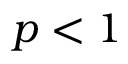<formula> <loc_0><loc_0><loc_500><loc_500>p < 1</formula> 